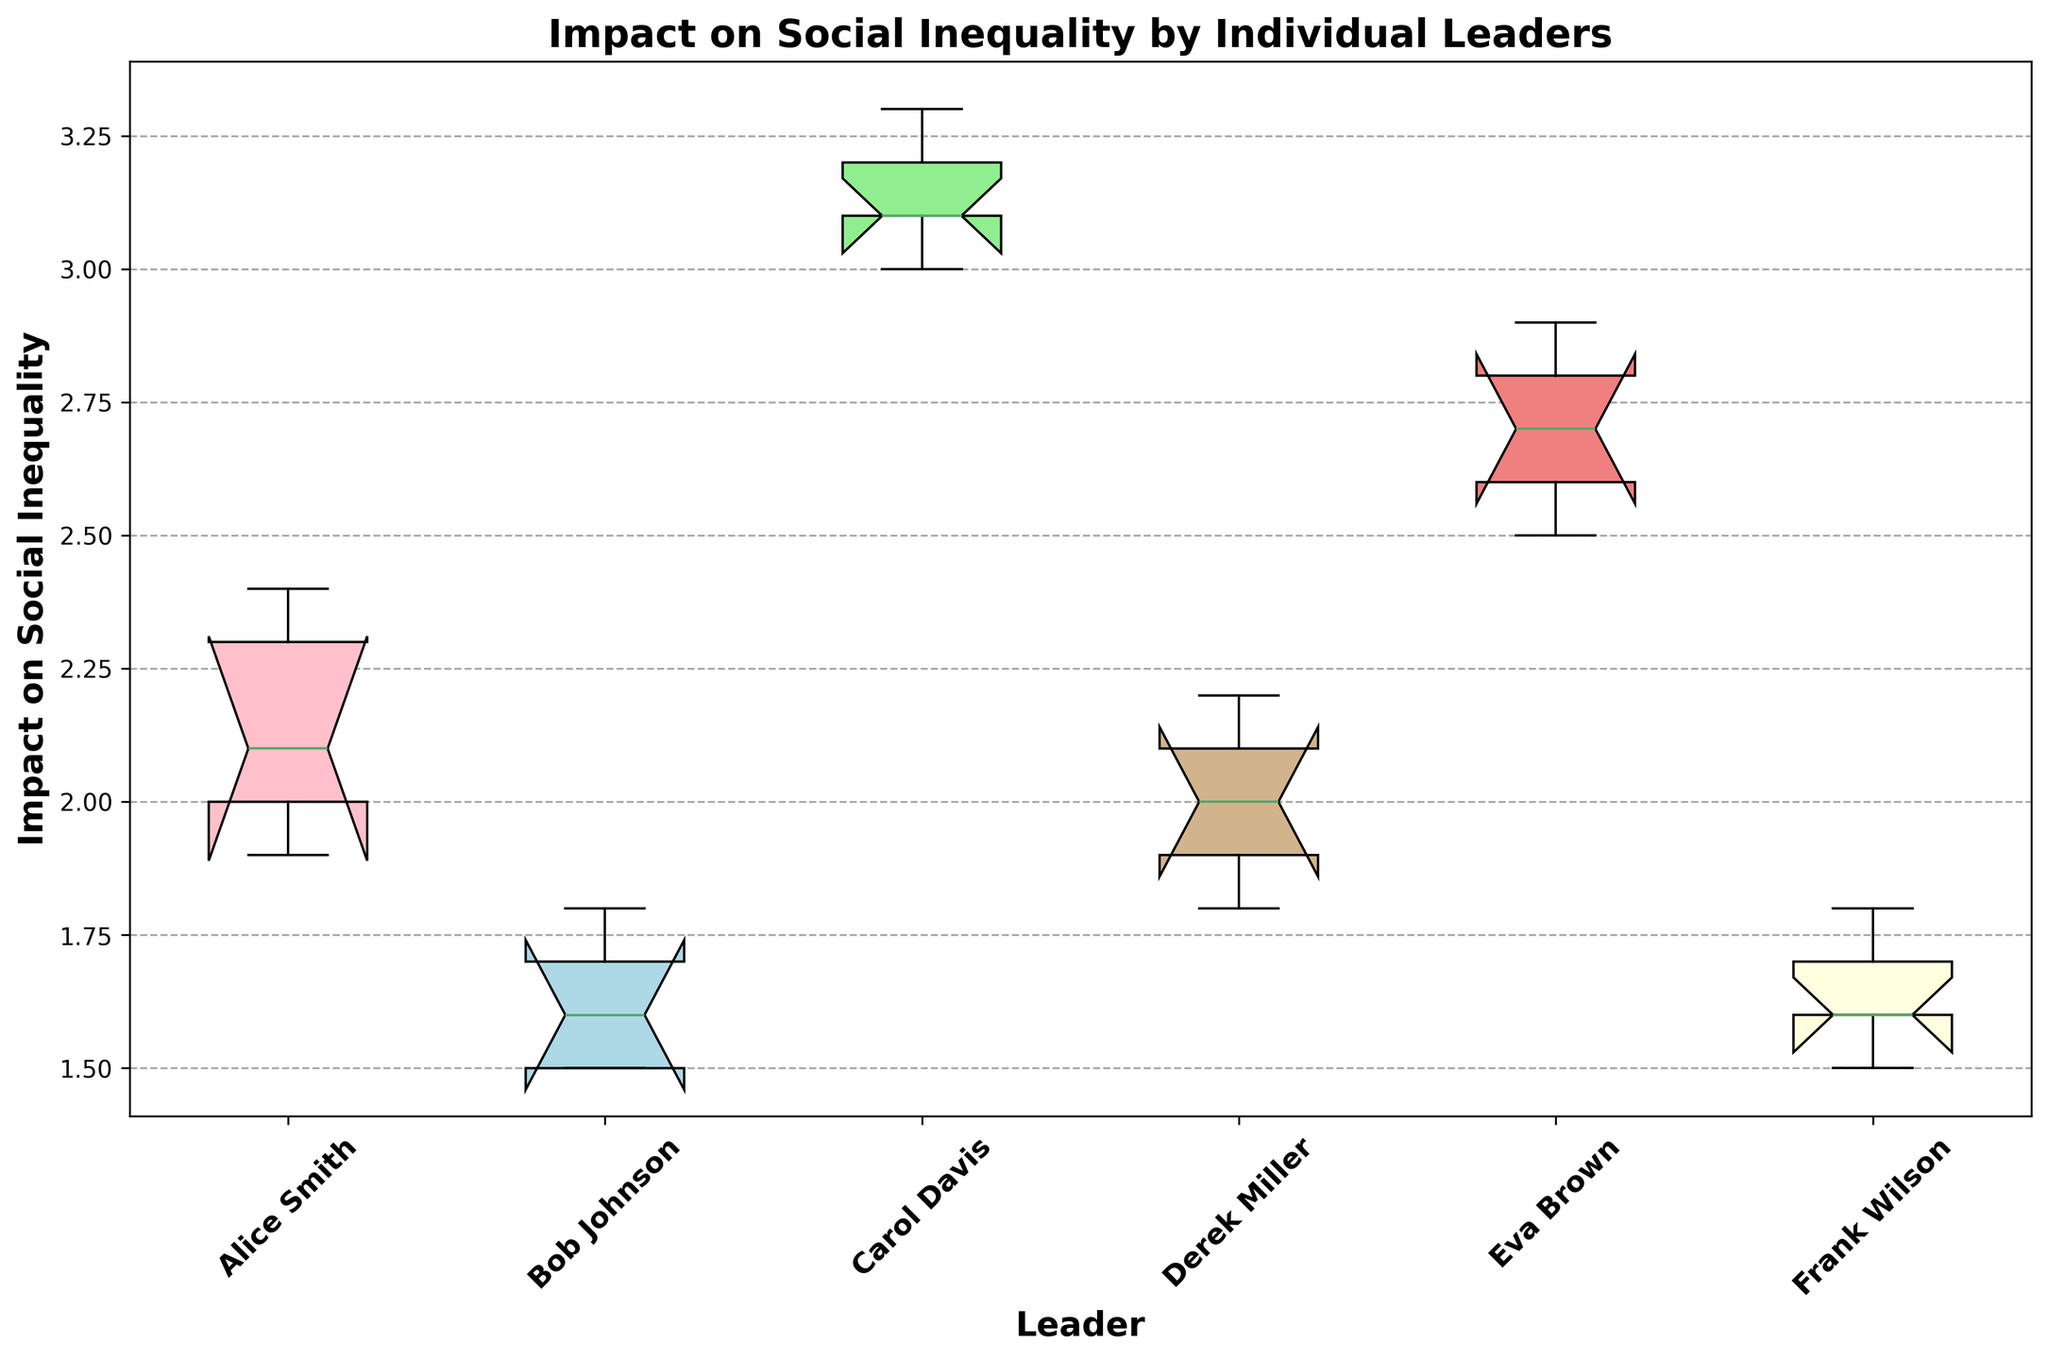What's the median impact on social inequality by Alice Smith? To find the median, we need to order Alice Smith's ImpactOnSocialInequality values (1.9, 2.0, 2.1, 2.3, 2.4) and find the middle one. The medians are automatically marked with a line in the middle of each box in the box plot, and for Alice Smith, the value is 2.1
Answer: 2.1 Which leader has the highest median impact on social inequality? On the box plot, the median is indicated by the line inside each box. Among all the leaders, Carol Davis’s median is the highest, visually around 3.1
Answer: Carol Davis What is the range of impacts on social inequality for Bob Johnson? To find the range, we need to subtract the smallest value from the largest value. On the box plot, the bottom and top edges of the box (lower and upper quartiles) can be used to estimate this. For Bob Johnson, the lower quartile is approximately 1.5 and the upper quartile is approximately 1.8. Therefore, the range is approximately 1.8 - 1.5 = 0.3
Answer: 0.3 How does the impact on social inequality by Derek Miller compare to Alice Smith? We compare the median and the quartiles of the boxes. Derek Miller's median appears to be around 2.0, and Alice Smith's median is slightly higher at 2.1. Their interquartile ranges overlap significantly, indicating similar impacts.
Answer: Similar Which leader shows the least variability in the impact on social inequality? Variability in a box plot is shown by the length of the box (interquartile range). The leader with the shortest box has the least variability. Bob Johnson has the smallest interquartile range, making him the leader with the least variability.
Answer: Bob Johnson What colors represent Eva Brown and Frank Wilson? The box plot uses distinct colors for each leader. Eva Brown is represented by the light coral box, and Frank Wilson is represented by the light yellow box.
Answer: light coral for Eva Brown and light yellow for Frank Wilson What is the difference in median impact on social inequality between Carol Davis and Bob Johnson? For Carol Davis, the median is around 3.1, and for Bob Johnson, it is around 1.6. The difference is 3.1 - 1.6 = 1.5
Answer: 1.5 Which leader has the widest spread in their impact on social inequality? The spread is shown by the length of the whiskers on both sides of the box. Carol Davis has the longest whiskers, indicating the widest spread in her impact on social inequality.
Answer: Carol Davis What is the interquartile range (IQR) of Eva Brown's impact on social inequality? The IQR is the range between the first quartile (bottom of the box) and the third quartile (top of the box). For Eva Brown, visually estimate the values of the quartiles as approximately 2.6 and 2.8. Therefore, the IQR is 2.8 - 2.6 = 0.2
Answer: 0.2 